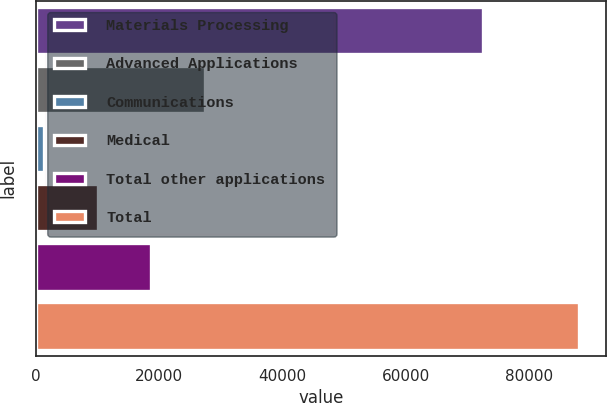<chart> <loc_0><loc_0><loc_500><loc_500><bar_chart><fcel>Materials Processing<fcel>Advanced Applications<fcel>Communications<fcel>Medical<fcel>Total other applications<fcel>Total<nl><fcel>72570<fcel>27350.4<fcel>1338<fcel>10008.8<fcel>18679.6<fcel>88046<nl></chart> 